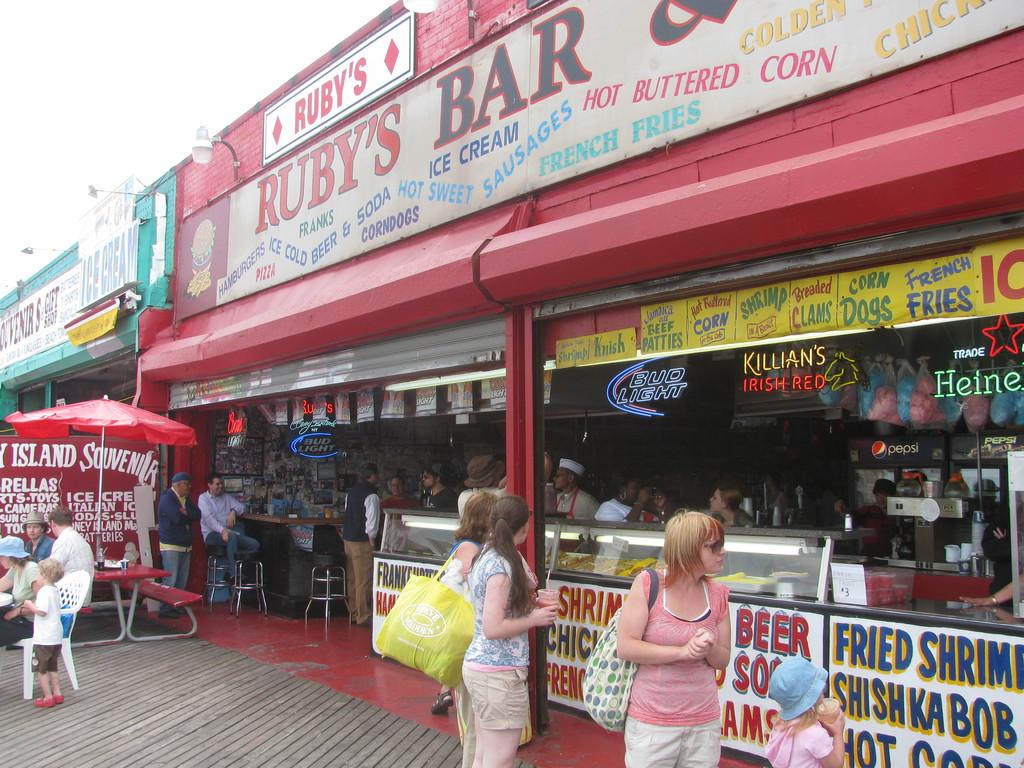Who's bar is this?
Provide a short and direct response. Ruby's. What restaurant is shown here?
Make the answer very short. Ruby's bar. 